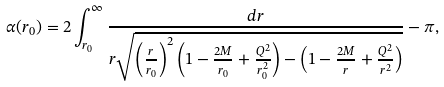Convert formula to latex. <formula><loc_0><loc_0><loc_500><loc_500>\alpha ( r _ { 0 } ) = 2 \int _ { r _ { 0 } } ^ { \infty } \frac { d r } { r \sqrt { \left ( \frac { r } { r _ { 0 } } \right ) ^ { 2 } \left ( 1 - \frac { 2 M } { r _ { 0 } } + \frac { Q ^ { 2 } } { r _ { 0 } ^ { 2 } } \right ) - \left ( 1 - \frac { 2 M } { r } + \frac { Q ^ { 2 } } { r ^ { 2 } } \right ) } } - \pi ,</formula> 